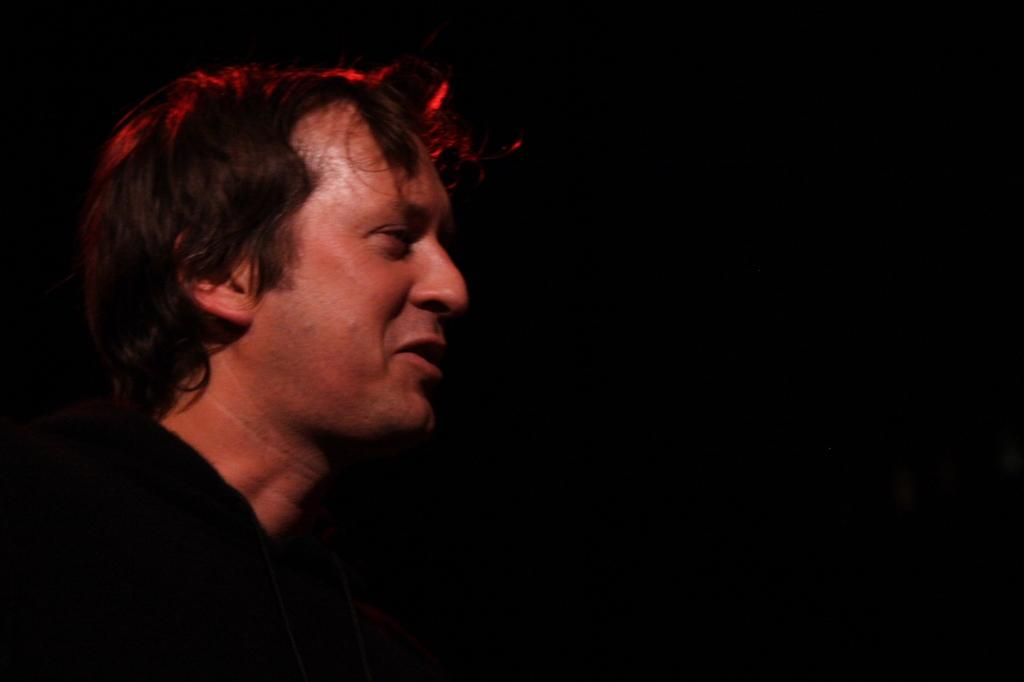What is present in the image? There is a person in the image. How does the person appear in the image? The person has a smiling face. What type of ball can be seen rolling along the coast in the image? There is no ball or coast present in the image; it only features a person with a smiling face. 